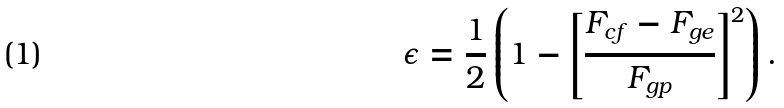Convert formula to latex. <formula><loc_0><loc_0><loc_500><loc_500>\epsilon = \frac { 1 } { 2 } \left ( 1 - \left [ \frac { F _ { c f } - F _ { g e } } { F _ { g p } } \right ] ^ { 2 } \right ) .</formula> 